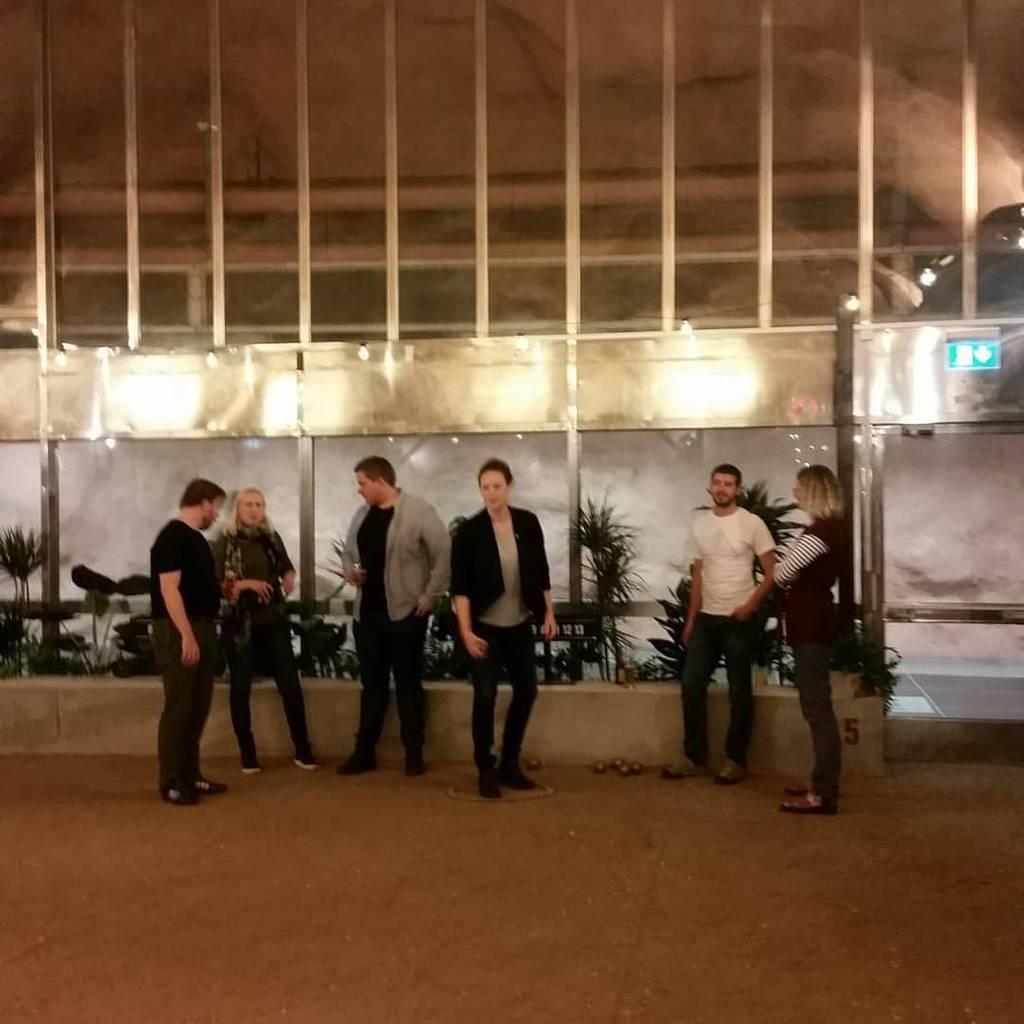How many people are present in the image? There are six people in the image. What are the people standing in front of? The people are standing in front of plants. What can be seen in the background of the image? There is some construction visible in the background of the image. What theory is the boy in the image trying to prove? There is no boy present in the image, and therefore no theory can be associated with the image. 